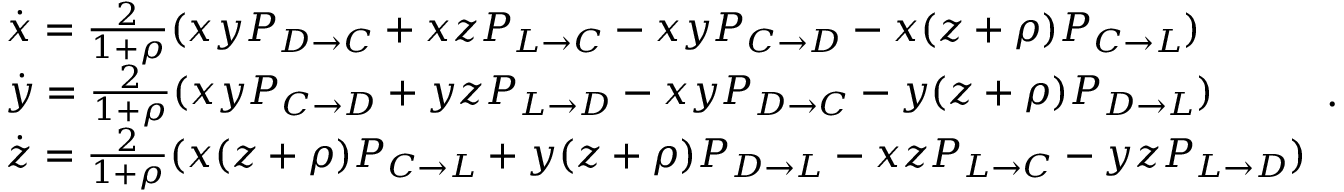Convert formula to latex. <formula><loc_0><loc_0><loc_500><loc_500>\begin{array} { l } { \dot { x } = \frac { 2 } { 1 + \rho } ( x y P _ { D \to C } + x z P _ { L \to C } - x y P _ { C \to D } - x ( z + \rho ) P _ { C \to L } ) } \\ { \dot { y } = \frac { 2 } { 1 + \rho } ( x y P _ { C \to D } + y z P _ { L \to D } - x y P _ { D \to C } - y ( z + \rho ) P _ { D \to L } ) } \\ { \dot { z } = \frac { 2 } { 1 + \rho } ( x ( z + \rho ) P _ { C \to L } + y ( z + \rho ) P _ { D \to L } - x z P _ { L \to C } - y z P _ { L \to D } ) } \end{array} .</formula> 